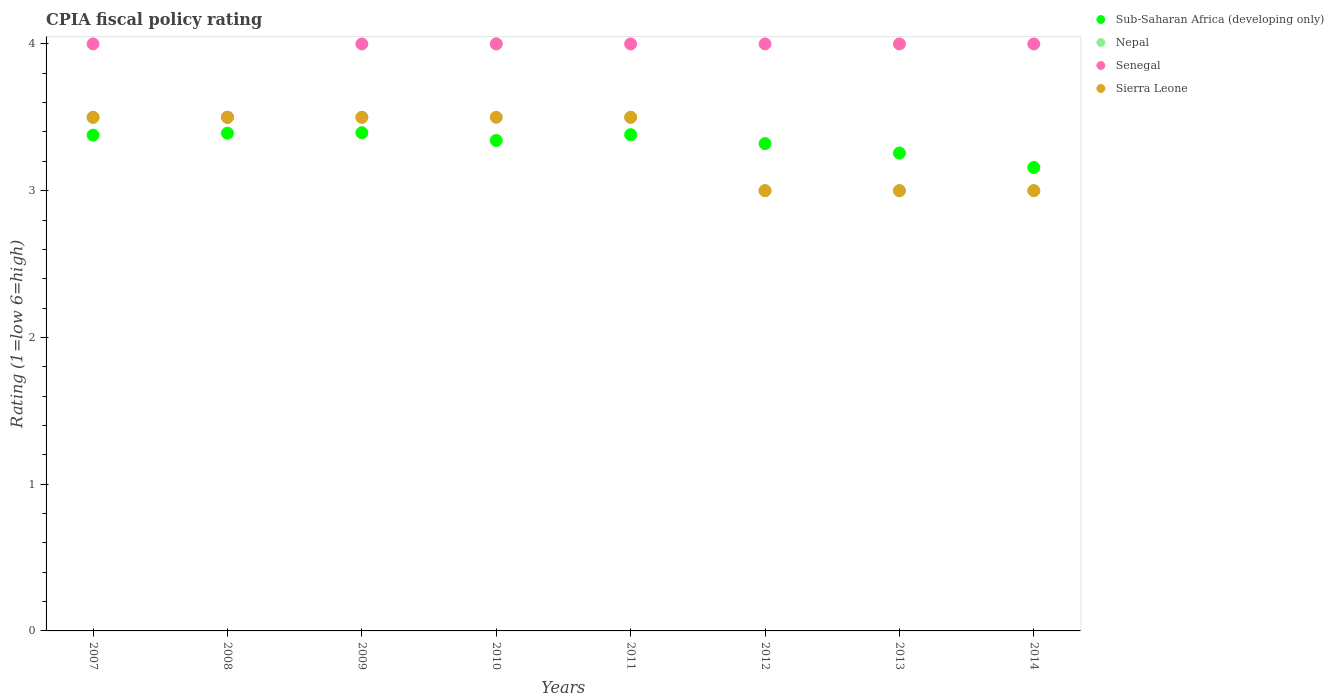Across all years, what is the maximum CPIA rating in Sub-Saharan Africa (developing only)?
Your answer should be very brief. 3.39. In which year was the CPIA rating in Nepal minimum?
Offer a terse response. 2012. What is the total CPIA rating in Sub-Saharan Africa (developing only) in the graph?
Provide a short and direct response. 26.62. What is the difference between the CPIA rating in Sub-Saharan Africa (developing only) in 2010 and that in 2012?
Provide a short and direct response. 0.02. What is the difference between the CPIA rating in Sierra Leone in 2011 and the CPIA rating in Sub-Saharan Africa (developing only) in 2014?
Your response must be concise. 0.34. What is the average CPIA rating in Sierra Leone per year?
Make the answer very short. 3.31. What is the ratio of the CPIA rating in Sub-Saharan Africa (developing only) in 2009 to that in 2014?
Offer a terse response. 1.07. Is the difference between the CPIA rating in Nepal in 2011 and 2013 greater than the difference between the CPIA rating in Sierra Leone in 2011 and 2013?
Your response must be concise. No. What is the difference between the highest and the second highest CPIA rating in Sub-Saharan Africa (developing only)?
Keep it short and to the point. 0. In how many years, is the CPIA rating in Sub-Saharan Africa (developing only) greater than the average CPIA rating in Sub-Saharan Africa (developing only) taken over all years?
Your response must be concise. 5. Is the sum of the CPIA rating in Nepal in 2009 and 2013 greater than the maximum CPIA rating in Senegal across all years?
Keep it short and to the point. Yes. Is the CPIA rating in Sub-Saharan Africa (developing only) strictly greater than the CPIA rating in Sierra Leone over the years?
Ensure brevity in your answer.  No. Is the CPIA rating in Sierra Leone strictly less than the CPIA rating in Senegal over the years?
Your answer should be very brief. No. How many legend labels are there?
Provide a succinct answer. 4. What is the title of the graph?
Provide a succinct answer. CPIA fiscal policy rating. Does "Monaco" appear as one of the legend labels in the graph?
Your response must be concise. No. What is the label or title of the X-axis?
Keep it short and to the point. Years. What is the label or title of the Y-axis?
Keep it short and to the point. Rating (1=low 6=high). What is the Rating (1=low 6=high) of Sub-Saharan Africa (developing only) in 2007?
Give a very brief answer. 3.38. What is the Rating (1=low 6=high) in Nepal in 2007?
Your response must be concise. 3.5. What is the Rating (1=low 6=high) of Senegal in 2007?
Give a very brief answer. 4. What is the Rating (1=low 6=high) of Sierra Leone in 2007?
Keep it short and to the point. 3.5. What is the Rating (1=low 6=high) in Sub-Saharan Africa (developing only) in 2008?
Offer a very short reply. 3.39. What is the Rating (1=low 6=high) of Nepal in 2008?
Ensure brevity in your answer.  3.5. What is the Rating (1=low 6=high) in Senegal in 2008?
Your answer should be very brief. 3.5. What is the Rating (1=low 6=high) of Sub-Saharan Africa (developing only) in 2009?
Your answer should be compact. 3.39. What is the Rating (1=low 6=high) in Nepal in 2009?
Ensure brevity in your answer.  3.5. What is the Rating (1=low 6=high) in Senegal in 2009?
Your answer should be compact. 4. What is the Rating (1=low 6=high) in Sub-Saharan Africa (developing only) in 2010?
Make the answer very short. 3.34. What is the Rating (1=low 6=high) of Nepal in 2010?
Offer a very short reply. 4. What is the Rating (1=low 6=high) in Sierra Leone in 2010?
Your response must be concise. 3.5. What is the Rating (1=low 6=high) in Sub-Saharan Africa (developing only) in 2011?
Your answer should be compact. 3.38. What is the Rating (1=low 6=high) of Senegal in 2011?
Your answer should be very brief. 4. What is the Rating (1=low 6=high) of Sub-Saharan Africa (developing only) in 2012?
Provide a succinct answer. 3.32. What is the Rating (1=low 6=high) in Sub-Saharan Africa (developing only) in 2013?
Your response must be concise. 3.26. What is the Rating (1=low 6=high) of Sub-Saharan Africa (developing only) in 2014?
Your response must be concise. 3.16. What is the Rating (1=low 6=high) in Nepal in 2014?
Give a very brief answer. 3. What is the Rating (1=low 6=high) in Senegal in 2014?
Your answer should be very brief. 4. What is the Rating (1=low 6=high) in Sierra Leone in 2014?
Your response must be concise. 3. Across all years, what is the maximum Rating (1=low 6=high) in Sub-Saharan Africa (developing only)?
Offer a very short reply. 3.39. Across all years, what is the maximum Rating (1=low 6=high) in Sierra Leone?
Offer a very short reply. 3.5. Across all years, what is the minimum Rating (1=low 6=high) in Sub-Saharan Africa (developing only)?
Your response must be concise. 3.16. Across all years, what is the minimum Rating (1=low 6=high) of Senegal?
Your answer should be compact. 3.5. What is the total Rating (1=low 6=high) of Sub-Saharan Africa (developing only) in the graph?
Offer a very short reply. 26.62. What is the total Rating (1=low 6=high) of Senegal in the graph?
Your answer should be very brief. 31.5. What is the total Rating (1=low 6=high) in Sierra Leone in the graph?
Give a very brief answer. 26.5. What is the difference between the Rating (1=low 6=high) in Sub-Saharan Africa (developing only) in 2007 and that in 2008?
Offer a terse response. -0.01. What is the difference between the Rating (1=low 6=high) in Senegal in 2007 and that in 2008?
Your answer should be very brief. 0.5. What is the difference between the Rating (1=low 6=high) in Sub-Saharan Africa (developing only) in 2007 and that in 2009?
Give a very brief answer. -0.02. What is the difference between the Rating (1=low 6=high) of Senegal in 2007 and that in 2009?
Ensure brevity in your answer.  0. What is the difference between the Rating (1=low 6=high) in Sub-Saharan Africa (developing only) in 2007 and that in 2010?
Provide a short and direct response. 0.04. What is the difference between the Rating (1=low 6=high) in Sierra Leone in 2007 and that in 2010?
Provide a short and direct response. 0. What is the difference between the Rating (1=low 6=high) of Sub-Saharan Africa (developing only) in 2007 and that in 2011?
Give a very brief answer. -0. What is the difference between the Rating (1=low 6=high) in Nepal in 2007 and that in 2011?
Your response must be concise. 0. What is the difference between the Rating (1=low 6=high) in Senegal in 2007 and that in 2011?
Your answer should be compact. 0. What is the difference between the Rating (1=low 6=high) of Sierra Leone in 2007 and that in 2011?
Make the answer very short. 0. What is the difference between the Rating (1=low 6=high) in Sub-Saharan Africa (developing only) in 2007 and that in 2012?
Offer a very short reply. 0.06. What is the difference between the Rating (1=low 6=high) of Nepal in 2007 and that in 2012?
Keep it short and to the point. 0.5. What is the difference between the Rating (1=low 6=high) of Senegal in 2007 and that in 2012?
Offer a terse response. 0. What is the difference between the Rating (1=low 6=high) of Sierra Leone in 2007 and that in 2012?
Give a very brief answer. 0.5. What is the difference between the Rating (1=low 6=high) in Sub-Saharan Africa (developing only) in 2007 and that in 2013?
Provide a succinct answer. 0.12. What is the difference between the Rating (1=low 6=high) in Nepal in 2007 and that in 2013?
Your answer should be very brief. 0.5. What is the difference between the Rating (1=low 6=high) of Senegal in 2007 and that in 2013?
Ensure brevity in your answer.  0. What is the difference between the Rating (1=low 6=high) of Sierra Leone in 2007 and that in 2013?
Offer a terse response. 0.5. What is the difference between the Rating (1=low 6=high) of Sub-Saharan Africa (developing only) in 2007 and that in 2014?
Give a very brief answer. 0.22. What is the difference between the Rating (1=low 6=high) of Nepal in 2007 and that in 2014?
Your response must be concise. 0.5. What is the difference between the Rating (1=low 6=high) of Sierra Leone in 2007 and that in 2014?
Provide a short and direct response. 0.5. What is the difference between the Rating (1=low 6=high) of Sub-Saharan Africa (developing only) in 2008 and that in 2009?
Provide a succinct answer. -0. What is the difference between the Rating (1=low 6=high) of Nepal in 2008 and that in 2009?
Your answer should be compact. 0. What is the difference between the Rating (1=low 6=high) of Senegal in 2008 and that in 2009?
Keep it short and to the point. -0.5. What is the difference between the Rating (1=low 6=high) in Sierra Leone in 2008 and that in 2009?
Your answer should be very brief. 0. What is the difference between the Rating (1=low 6=high) in Sub-Saharan Africa (developing only) in 2008 and that in 2010?
Your answer should be compact. 0.05. What is the difference between the Rating (1=low 6=high) in Sierra Leone in 2008 and that in 2010?
Offer a very short reply. 0. What is the difference between the Rating (1=low 6=high) of Sub-Saharan Africa (developing only) in 2008 and that in 2011?
Provide a succinct answer. 0.01. What is the difference between the Rating (1=low 6=high) of Senegal in 2008 and that in 2011?
Provide a succinct answer. -0.5. What is the difference between the Rating (1=low 6=high) of Sub-Saharan Africa (developing only) in 2008 and that in 2012?
Provide a succinct answer. 0.07. What is the difference between the Rating (1=low 6=high) of Nepal in 2008 and that in 2012?
Your answer should be compact. 0.5. What is the difference between the Rating (1=low 6=high) of Senegal in 2008 and that in 2012?
Offer a terse response. -0.5. What is the difference between the Rating (1=low 6=high) of Sierra Leone in 2008 and that in 2012?
Ensure brevity in your answer.  0.5. What is the difference between the Rating (1=low 6=high) in Sub-Saharan Africa (developing only) in 2008 and that in 2013?
Your answer should be very brief. 0.14. What is the difference between the Rating (1=low 6=high) in Sierra Leone in 2008 and that in 2013?
Your answer should be compact. 0.5. What is the difference between the Rating (1=low 6=high) of Sub-Saharan Africa (developing only) in 2008 and that in 2014?
Keep it short and to the point. 0.23. What is the difference between the Rating (1=low 6=high) of Nepal in 2008 and that in 2014?
Provide a short and direct response. 0.5. What is the difference between the Rating (1=low 6=high) in Senegal in 2008 and that in 2014?
Give a very brief answer. -0.5. What is the difference between the Rating (1=low 6=high) of Sub-Saharan Africa (developing only) in 2009 and that in 2010?
Offer a terse response. 0.05. What is the difference between the Rating (1=low 6=high) in Senegal in 2009 and that in 2010?
Make the answer very short. 0. What is the difference between the Rating (1=low 6=high) in Sub-Saharan Africa (developing only) in 2009 and that in 2011?
Provide a succinct answer. 0.01. What is the difference between the Rating (1=low 6=high) in Nepal in 2009 and that in 2011?
Keep it short and to the point. 0. What is the difference between the Rating (1=low 6=high) in Sub-Saharan Africa (developing only) in 2009 and that in 2012?
Your response must be concise. 0.07. What is the difference between the Rating (1=low 6=high) of Sierra Leone in 2009 and that in 2012?
Offer a terse response. 0.5. What is the difference between the Rating (1=low 6=high) of Sub-Saharan Africa (developing only) in 2009 and that in 2013?
Ensure brevity in your answer.  0.14. What is the difference between the Rating (1=low 6=high) of Sierra Leone in 2009 and that in 2013?
Offer a very short reply. 0.5. What is the difference between the Rating (1=low 6=high) in Sub-Saharan Africa (developing only) in 2009 and that in 2014?
Offer a terse response. 0.24. What is the difference between the Rating (1=low 6=high) in Nepal in 2009 and that in 2014?
Your answer should be very brief. 0.5. What is the difference between the Rating (1=low 6=high) of Senegal in 2009 and that in 2014?
Provide a short and direct response. 0. What is the difference between the Rating (1=low 6=high) of Sierra Leone in 2009 and that in 2014?
Make the answer very short. 0.5. What is the difference between the Rating (1=low 6=high) in Sub-Saharan Africa (developing only) in 2010 and that in 2011?
Your answer should be compact. -0.04. What is the difference between the Rating (1=low 6=high) of Nepal in 2010 and that in 2011?
Keep it short and to the point. 0.5. What is the difference between the Rating (1=low 6=high) of Senegal in 2010 and that in 2011?
Your answer should be very brief. 0. What is the difference between the Rating (1=low 6=high) in Sub-Saharan Africa (developing only) in 2010 and that in 2012?
Give a very brief answer. 0.02. What is the difference between the Rating (1=low 6=high) in Senegal in 2010 and that in 2012?
Offer a very short reply. 0. What is the difference between the Rating (1=low 6=high) of Sub-Saharan Africa (developing only) in 2010 and that in 2013?
Your answer should be very brief. 0.09. What is the difference between the Rating (1=low 6=high) of Nepal in 2010 and that in 2013?
Offer a very short reply. 1. What is the difference between the Rating (1=low 6=high) in Senegal in 2010 and that in 2013?
Ensure brevity in your answer.  0. What is the difference between the Rating (1=low 6=high) in Sierra Leone in 2010 and that in 2013?
Offer a very short reply. 0.5. What is the difference between the Rating (1=low 6=high) in Sub-Saharan Africa (developing only) in 2010 and that in 2014?
Your answer should be compact. 0.18. What is the difference between the Rating (1=low 6=high) in Senegal in 2010 and that in 2014?
Offer a terse response. 0. What is the difference between the Rating (1=low 6=high) of Sub-Saharan Africa (developing only) in 2011 and that in 2012?
Offer a very short reply. 0.06. What is the difference between the Rating (1=low 6=high) in Nepal in 2011 and that in 2012?
Provide a succinct answer. 0.5. What is the difference between the Rating (1=low 6=high) of Sierra Leone in 2011 and that in 2012?
Provide a short and direct response. 0.5. What is the difference between the Rating (1=low 6=high) in Sub-Saharan Africa (developing only) in 2011 and that in 2013?
Offer a terse response. 0.13. What is the difference between the Rating (1=low 6=high) in Nepal in 2011 and that in 2013?
Give a very brief answer. 0.5. What is the difference between the Rating (1=low 6=high) in Sub-Saharan Africa (developing only) in 2011 and that in 2014?
Provide a short and direct response. 0.22. What is the difference between the Rating (1=low 6=high) in Nepal in 2011 and that in 2014?
Offer a very short reply. 0.5. What is the difference between the Rating (1=low 6=high) in Sub-Saharan Africa (developing only) in 2012 and that in 2013?
Offer a very short reply. 0.06. What is the difference between the Rating (1=low 6=high) in Nepal in 2012 and that in 2013?
Offer a terse response. 0. What is the difference between the Rating (1=low 6=high) of Sub-Saharan Africa (developing only) in 2012 and that in 2014?
Keep it short and to the point. 0.16. What is the difference between the Rating (1=low 6=high) of Nepal in 2012 and that in 2014?
Provide a short and direct response. 0. What is the difference between the Rating (1=low 6=high) of Sub-Saharan Africa (developing only) in 2013 and that in 2014?
Your answer should be compact. 0.1. What is the difference between the Rating (1=low 6=high) of Nepal in 2013 and that in 2014?
Give a very brief answer. 0. What is the difference between the Rating (1=low 6=high) of Sub-Saharan Africa (developing only) in 2007 and the Rating (1=low 6=high) of Nepal in 2008?
Offer a very short reply. -0.12. What is the difference between the Rating (1=low 6=high) in Sub-Saharan Africa (developing only) in 2007 and the Rating (1=low 6=high) in Senegal in 2008?
Provide a short and direct response. -0.12. What is the difference between the Rating (1=low 6=high) in Sub-Saharan Africa (developing only) in 2007 and the Rating (1=low 6=high) in Sierra Leone in 2008?
Keep it short and to the point. -0.12. What is the difference between the Rating (1=low 6=high) in Sub-Saharan Africa (developing only) in 2007 and the Rating (1=low 6=high) in Nepal in 2009?
Ensure brevity in your answer.  -0.12. What is the difference between the Rating (1=low 6=high) in Sub-Saharan Africa (developing only) in 2007 and the Rating (1=low 6=high) in Senegal in 2009?
Offer a very short reply. -0.62. What is the difference between the Rating (1=low 6=high) of Sub-Saharan Africa (developing only) in 2007 and the Rating (1=low 6=high) of Sierra Leone in 2009?
Make the answer very short. -0.12. What is the difference between the Rating (1=low 6=high) in Sub-Saharan Africa (developing only) in 2007 and the Rating (1=low 6=high) in Nepal in 2010?
Offer a terse response. -0.62. What is the difference between the Rating (1=low 6=high) of Sub-Saharan Africa (developing only) in 2007 and the Rating (1=low 6=high) of Senegal in 2010?
Your answer should be very brief. -0.62. What is the difference between the Rating (1=low 6=high) of Sub-Saharan Africa (developing only) in 2007 and the Rating (1=low 6=high) of Sierra Leone in 2010?
Offer a very short reply. -0.12. What is the difference between the Rating (1=low 6=high) of Senegal in 2007 and the Rating (1=low 6=high) of Sierra Leone in 2010?
Offer a very short reply. 0.5. What is the difference between the Rating (1=low 6=high) of Sub-Saharan Africa (developing only) in 2007 and the Rating (1=low 6=high) of Nepal in 2011?
Ensure brevity in your answer.  -0.12. What is the difference between the Rating (1=low 6=high) of Sub-Saharan Africa (developing only) in 2007 and the Rating (1=low 6=high) of Senegal in 2011?
Offer a terse response. -0.62. What is the difference between the Rating (1=low 6=high) of Sub-Saharan Africa (developing only) in 2007 and the Rating (1=low 6=high) of Sierra Leone in 2011?
Give a very brief answer. -0.12. What is the difference between the Rating (1=low 6=high) in Nepal in 2007 and the Rating (1=low 6=high) in Sierra Leone in 2011?
Your response must be concise. 0. What is the difference between the Rating (1=low 6=high) of Sub-Saharan Africa (developing only) in 2007 and the Rating (1=low 6=high) of Nepal in 2012?
Make the answer very short. 0.38. What is the difference between the Rating (1=low 6=high) in Sub-Saharan Africa (developing only) in 2007 and the Rating (1=low 6=high) in Senegal in 2012?
Provide a succinct answer. -0.62. What is the difference between the Rating (1=low 6=high) in Sub-Saharan Africa (developing only) in 2007 and the Rating (1=low 6=high) in Sierra Leone in 2012?
Offer a terse response. 0.38. What is the difference between the Rating (1=low 6=high) of Nepal in 2007 and the Rating (1=low 6=high) of Sierra Leone in 2012?
Your response must be concise. 0.5. What is the difference between the Rating (1=low 6=high) of Senegal in 2007 and the Rating (1=low 6=high) of Sierra Leone in 2012?
Ensure brevity in your answer.  1. What is the difference between the Rating (1=low 6=high) of Sub-Saharan Africa (developing only) in 2007 and the Rating (1=low 6=high) of Nepal in 2013?
Ensure brevity in your answer.  0.38. What is the difference between the Rating (1=low 6=high) of Sub-Saharan Africa (developing only) in 2007 and the Rating (1=low 6=high) of Senegal in 2013?
Keep it short and to the point. -0.62. What is the difference between the Rating (1=low 6=high) in Sub-Saharan Africa (developing only) in 2007 and the Rating (1=low 6=high) in Sierra Leone in 2013?
Make the answer very short. 0.38. What is the difference between the Rating (1=low 6=high) of Nepal in 2007 and the Rating (1=low 6=high) of Senegal in 2013?
Keep it short and to the point. -0.5. What is the difference between the Rating (1=low 6=high) in Nepal in 2007 and the Rating (1=low 6=high) in Sierra Leone in 2013?
Provide a short and direct response. 0.5. What is the difference between the Rating (1=low 6=high) in Sub-Saharan Africa (developing only) in 2007 and the Rating (1=low 6=high) in Nepal in 2014?
Provide a short and direct response. 0.38. What is the difference between the Rating (1=low 6=high) in Sub-Saharan Africa (developing only) in 2007 and the Rating (1=low 6=high) in Senegal in 2014?
Offer a very short reply. -0.62. What is the difference between the Rating (1=low 6=high) of Sub-Saharan Africa (developing only) in 2007 and the Rating (1=low 6=high) of Sierra Leone in 2014?
Give a very brief answer. 0.38. What is the difference between the Rating (1=low 6=high) in Nepal in 2007 and the Rating (1=low 6=high) in Senegal in 2014?
Provide a succinct answer. -0.5. What is the difference between the Rating (1=low 6=high) in Senegal in 2007 and the Rating (1=low 6=high) in Sierra Leone in 2014?
Give a very brief answer. 1. What is the difference between the Rating (1=low 6=high) in Sub-Saharan Africa (developing only) in 2008 and the Rating (1=low 6=high) in Nepal in 2009?
Make the answer very short. -0.11. What is the difference between the Rating (1=low 6=high) in Sub-Saharan Africa (developing only) in 2008 and the Rating (1=low 6=high) in Senegal in 2009?
Provide a succinct answer. -0.61. What is the difference between the Rating (1=low 6=high) in Sub-Saharan Africa (developing only) in 2008 and the Rating (1=low 6=high) in Sierra Leone in 2009?
Your response must be concise. -0.11. What is the difference between the Rating (1=low 6=high) in Nepal in 2008 and the Rating (1=low 6=high) in Senegal in 2009?
Your response must be concise. -0.5. What is the difference between the Rating (1=low 6=high) of Nepal in 2008 and the Rating (1=low 6=high) of Sierra Leone in 2009?
Offer a very short reply. 0. What is the difference between the Rating (1=low 6=high) of Senegal in 2008 and the Rating (1=low 6=high) of Sierra Leone in 2009?
Make the answer very short. 0. What is the difference between the Rating (1=low 6=high) in Sub-Saharan Africa (developing only) in 2008 and the Rating (1=low 6=high) in Nepal in 2010?
Ensure brevity in your answer.  -0.61. What is the difference between the Rating (1=low 6=high) in Sub-Saharan Africa (developing only) in 2008 and the Rating (1=low 6=high) in Senegal in 2010?
Provide a short and direct response. -0.61. What is the difference between the Rating (1=low 6=high) of Sub-Saharan Africa (developing only) in 2008 and the Rating (1=low 6=high) of Sierra Leone in 2010?
Your response must be concise. -0.11. What is the difference between the Rating (1=low 6=high) in Nepal in 2008 and the Rating (1=low 6=high) in Senegal in 2010?
Provide a short and direct response. -0.5. What is the difference between the Rating (1=low 6=high) of Nepal in 2008 and the Rating (1=low 6=high) of Sierra Leone in 2010?
Make the answer very short. 0. What is the difference between the Rating (1=low 6=high) of Senegal in 2008 and the Rating (1=low 6=high) of Sierra Leone in 2010?
Make the answer very short. 0. What is the difference between the Rating (1=low 6=high) of Sub-Saharan Africa (developing only) in 2008 and the Rating (1=low 6=high) of Nepal in 2011?
Ensure brevity in your answer.  -0.11. What is the difference between the Rating (1=low 6=high) in Sub-Saharan Africa (developing only) in 2008 and the Rating (1=low 6=high) in Senegal in 2011?
Your response must be concise. -0.61. What is the difference between the Rating (1=low 6=high) in Sub-Saharan Africa (developing only) in 2008 and the Rating (1=low 6=high) in Sierra Leone in 2011?
Your response must be concise. -0.11. What is the difference between the Rating (1=low 6=high) in Nepal in 2008 and the Rating (1=low 6=high) in Senegal in 2011?
Your response must be concise. -0.5. What is the difference between the Rating (1=low 6=high) of Nepal in 2008 and the Rating (1=low 6=high) of Sierra Leone in 2011?
Provide a short and direct response. 0. What is the difference between the Rating (1=low 6=high) in Senegal in 2008 and the Rating (1=low 6=high) in Sierra Leone in 2011?
Offer a very short reply. 0. What is the difference between the Rating (1=low 6=high) of Sub-Saharan Africa (developing only) in 2008 and the Rating (1=low 6=high) of Nepal in 2012?
Ensure brevity in your answer.  0.39. What is the difference between the Rating (1=low 6=high) in Sub-Saharan Africa (developing only) in 2008 and the Rating (1=low 6=high) in Senegal in 2012?
Give a very brief answer. -0.61. What is the difference between the Rating (1=low 6=high) in Sub-Saharan Africa (developing only) in 2008 and the Rating (1=low 6=high) in Sierra Leone in 2012?
Give a very brief answer. 0.39. What is the difference between the Rating (1=low 6=high) of Nepal in 2008 and the Rating (1=low 6=high) of Sierra Leone in 2012?
Keep it short and to the point. 0.5. What is the difference between the Rating (1=low 6=high) of Sub-Saharan Africa (developing only) in 2008 and the Rating (1=low 6=high) of Nepal in 2013?
Provide a succinct answer. 0.39. What is the difference between the Rating (1=low 6=high) in Sub-Saharan Africa (developing only) in 2008 and the Rating (1=low 6=high) in Senegal in 2013?
Your answer should be compact. -0.61. What is the difference between the Rating (1=low 6=high) of Sub-Saharan Africa (developing only) in 2008 and the Rating (1=low 6=high) of Sierra Leone in 2013?
Offer a very short reply. 0.39. What is the difference between the Rating (1=low 6=high) in Nepal in 2008 and the Rating (1=low 6=high) in Senegal in 2013?
Provide a succinct answer. -0.5. What is the difference between the Rating (1=low 6=high) in Sub-Saharan Africa (developing only) in 2008 and the Rating (1=low 6=high) in Nepal in 2014?
Provide a short and direct response. 0.39. What is the difference between the Rating (1=low 6=high) of Sub-Saharan Africa (developing only) in 2008 and the Rating (1=low 6=high) of Senegal in 2014?
Your answer should be compact. -0.61. What is the difference between the Rating (1=low 6=high) in Sub-Saharan Africa (developing only) in 2008 and the Rating (1=low 6=high) in Sierra Leone in 2014?
Provide a succinct answer. 0.39. What is the difference between the Rating (1=low 6=high) of Nepal in 2008 and the Rating (1=low 6=high) of Sierra Leone in 2014?
Your response must be concise. 0.5. What is the difference between the Rating (1=low 6=high) in Senegal in 2008 and the Rating (1=low 6=high) in Sierra Leone in 2014?
Keep it short and to the point. 0.5. What is the difference between the Rating (1=low 6=high) of Sub-Saharan Africa (developing only) in 2009 and the Rating (1=low 6=high) of Nepal in 2010?
Make the answer very short. -0.61. What is the difference between the Rating (1=low 6=high) of Sub-Saharan Africa (developing only) in 2009 and the Rating (1=low 6=high) of Senegal in 2010?
Your answer should be compact. -0.61. What is the difference between the Rating (1=low 6=high) in Sub-Saharan Africa (developing only) in 2009 and the Rating (1=low 6=high) in Sierra Leone in 2010?
Keep it short and to the point. -0.11. What is the difference between the Rating (1=low 6=high) in Nepal in 2009 and the Rating (1=low 6=high) in Senegal in 2010?
Keep it short and to the point. -0.5. What is the difference between the Rating (1=low 6=high) in Nepal in 2009 and the Rating (1=low 6=high) in Sierra Leone in 2010?
Make the answer very short. 0. What is the difference between the Rating (1=low 6=high) in Sub-Saharan Africa (developing only) in 2009 and the Rating (1=low 6=high) in Nepal in 2011?
Offer a terse response. -0.11. What is the difference between the Rating (1=low 6=high) in Sub-Saharan Africa (developing only) in 2009 and the Rating (1=low 6=high) in Senegal in 2011?
Provide a short and direct response. -0.61. What is the difference between the Rating (1=low 6=high) in Sub-Saharan Africa (developing only) in 2009 and the Rating (1=low 6=high) in Sierra Leone in 2011?
Provide a succinct answer. -0.11. What is the difference between the Rating (1=low 6=high) in Senegal in 2009 and the Rating (1=low 6=high) in Sierra Leone in 2011?
Provide a short and direct response. 0.5. What is the difference between the Rating (1=low 6=high) in Sub-Saharan Africa (developing only) in 2009 and the Rating (1=low 6=high) in Nepal in 2012?
Make the answer very short. 0.39. What is the difference between the Rating (1=low 6=high) in Sub-Saharan Africa (developing only) in 2009 and the Rating (1=low 6=high) in Senegal in 2012?
Ensure brevity in your answer.  -0.61. What is the difference between the Rating (1=low 6=high) of Sub-Saharan Africa (developing only) in 2009 and the Rating (1=low 6=high) of Sierra Leone in 2012?
Make the answer very short. 0.39. What is the difference between the Rating (1=low 6=high) in Nepal in 2009 and the Rating (1=low 6=high) in Senegal in 2012?
Provide a short and direct response. -0.5. What is the difference between the Rating (1=low 6=high) of Nepal in 2009 and the Rating (1=low 6=high) of Sierra Leone in 2012?
Your answer should be very brief. 0.5. What is the difference between the Rating (1=low 6=high) in Sub-Saharan Africa (developing only) in 2009 and the Rating (1=low 6=high) in Nepal in 2013?
Ensure brevity in your answer.  0.39. What is the difference between the Rating (1=low 6=high) of Sub-Saharan Africa (developing only) in 2009 and the Rating (1=low 6=high) of Senegal in 2013?
Offer a terse response. -0.61. What is the difference between the Rating (1=low 6=high) in Sub-Saharan Africa (developing only) in 2009 and the Rating (1=low 6=high) in Sierra Leone in 2013?
Provide a succinct answer. 0.39. What is the difference between the Rating (1=low 6=high) of Nepal in 2009 and the Rating (1=low 6=high) of Sierra Leone in 2013?
Ensure brevity in your answer.  0.5. What is the difference between the Rating (1=low 6=high) in Sub-Saharan Africa (developing only) in 2009 and the Rating (1=low 6=high) in Nepal in 2014?
Your answer should be very brief. 0.39. What is the difference between the Rating (1=low 6=high) of Sub-Saharan Africa (developing only) in 2009 and the Rating (1=low 6=high) of Senegal in 2014?
Offer a very short reply. -0.61. What is the difference between the Rating (1=low 6=high) of Sub-Saharan Africa (developing only) in 2009 and the Rating (1=low 6=high) of Sierra Leone in 2014?
Your response must be concise. 0.39. What is the difference between the Rating (1=low 6=high) in Nepal in 2009 and the Rating (1=low 6=high) in Senegal in 2014?
Offer a terse response. -0.5. What is the difference between the Rating (1=low 6=high) of Nepal in 2009 and the Rating (1=low 6=high) of Sierra Leone in 2014?
Ensure brevity in your answer.  0.5. What is the difference between the Rating (1=low 6=high) in Senegal in 2009 and the Rating (1=low 6=high) in Sierra Leone in 2014?
Make the answer very short. 1. What is the difference between the Rating (1=low 6=high) of Sub-Saharan Africa (developing only) in 2010 and the Rating (1=low 6=high) of Nepal in 2011?
Your answer should be very brief. -0.16. What is the difference between the Rating (1=low 6=high) of Sub-Saharan Africa (developing only) in 2010 and the Rating (1=low 6=high) of Senegal in 2011?
Provide a short and direct response. -0.66. What is the difference between the Rating (1=low 6=high) in Sub-Saharan Africa (developing only) in 2010 and the Rating (1=low 6=high) in Sierra Leone in 2011?
Ensure brevity in your answer.  -0.16. What is the difference between the Rating (1=low 6=high) in Sub-Saharan Africa (developing only) in 2010 and the Rating (1=low 6=high) in Nepal in 2012?
Offer a terse response. 0.34. What is the difference between the Rating (1=low 6=high) of Sub-Saharan Africa (developing only) in 2010 and the Rating (1=low 6=high) of Senegal in 2012?
Offer a terse response. -0.66. What is the difference between the Rating (1=low 6=high) of Sub-Saharan Africa (developing only) in 2010 and the Rating (1=low 6=high) of Sierra Leone in 2012?
Provide a succinct answer. 0.34. What is the difference between the Rating (1=low 6=high) in Nepal in 2010 and the Rating (1=low 6=high) in Sierra Leone in 2012?
Ensure brevity in your answer.  1. What is the difference between the Rating (1=low 6=high) in Sub-Saharan Africa (developing only) in 2010 and the Rating (1=low 6=high) in Nepal in 2013?
Keep it short and to the point. 0.34. What is the difference between the Rating (1=low 6=high) in Sub-Saharan Africa (developing only) in 2010 and the Rating (1=low 6=high) in Senegal in 2013?
Ensure brevity in your answer.  -0.66. What is the difference between the Rating (1=low 6=high) in Sub-Saharan Africa (developing only) in 2010 and the Rating (1=low 6=high) in Sierra Leone in 2013?
Offer a terse response. 0.34. What is the difference between the Rating (1=low 6=high) in Nepal in 2010 and the Rating (1=low 6=high) in Senegal in 2013?
Your response must be concise. 0. What is the difference between the Rating (1=low 6=high) of Sub-Saharan Africa (developing only) in 2010 and the Rating (1=low 6=high) of Nepal in 2014?
Ensure brevity in your answer.  0.34. What is the difference between the Rating (1=low 6=high) of Sub-Saharan Africa (developing only) in 2010 and the Rating (1=low 6=high) of Senegal in 2014?
Offer a terse response. -0.66. What is the difference between the Rating (1=low 6=high) in Sub-Saharan Africa (developing only) in 2010 and the Rating (1=low 6=high) in Sierra Leone in 2014?
Make the answer very short. 0.34. What is the difference between the Rating (1=low 6=high) of Nepal in 2010 and the Rating (1=low 6=high) of Sierra Leone in 2014?
Give a very brief answer. 1. What is the difference between the Rating (1=low 6=high) of Sub-Saharan Africa (developing only) in 2011 and the Rating (1=low 6=high) of Nepal in 2012?
Offer a very short reply. 0.38. What is the difference between the Rating (1=low 6=high) in Sub-Saharan Africa (developing only) in 2011 and the Rating (1=low 6=high) in Senegal in 2012?
Your answer should be compact. -0.62. What is the difference between the Rating (1=low 6=high) of Sub-Saharan Africa (developing only) in 2011 and the Rating (1=low 6=high) of Sierra Leone in 2012?
Keep it short and to the point. 0.38. What is the difference between the Rating (1=low 6=high) of Nepal in 2011 and the Rating (1=low 6=high) of Senegal in 2012?
Offer a terse response. -0.5. What is the difference between the Rating (1=low 6=high) of Nepal in 2011 and the Rating (1=low 6=high) of Sierra Leone in 2012?
Give a very brief answer. 0.5. What is the difference between the Rating (1=low 6=high) of Senegal in 2011 and the Rating (1=low 6=high) of Sierra Leone in 2012?
Your answer should be compact. 1. What is the difference between the Rating (1=low 6=high) in Sub-Saharan Africa (developing only) in 2011 and the Rating (1=low 6=high) in Nepal in 2013?
Your answer should be compact. 0.38. What is the difference between the Rating (1=low 6=high) of Sub-Saharan Africa (developing only) in 2011 and the Rating (1=low 6=high) of Senegal in 2013?
Your answer should be compact. -0.62. What is the difference between the Rating (1=low 6=high) of Sub-Saharan Africa (developing only) in 2011 and the Rating (1=low 6=high) of Sierra Leone in 2013?
Your answer should be very brief. 0.38. What is the difference between the Rating (1=low 6=high) of Sub-Saharan Africa (developing only) in 2011 and the Rating (1=low 6=high) of Nepal in 2014?
Your response must be concise. 0.38. What is the difference between the Rating (1=low 6=high) in Sub-Saharan Africa (developing only) in 2011 and the Rating (1=low 6=high) in Senegal in 2014?
Make the answer very short. -0.62. What is the difference between the Rating (1=low 6=high) of Sub-Saharan Africa (developing only) in 2011 and the Rating (1=low 6=high) of Sierra Leone in 2014?
Offer a terse response. 0.38. What is the difference between the Rating (1=low 6=high) of Nepal in 2011 and the Rating (1=low 6=high) of Senegal in 2014?
Provide a succinct answer. -0.5. What is the difference between the Rating (1=low 6=high) of Sub-Saharan Africa (developing only) in 2012 and the Rating (1=low 6=high) of Nepal in 2013?
Your response must be concise. 0.32. What is the difference between the Rating (1=low 6=high) of Sub-Saharan Africa (developing only) in 2012 and the Rating (1=low 6=high) of Senegal in 2013?
Keep it short and to the point. -0.68. What is the difference between the Rating (1=low 6=high) in Sub-Saharan Africa (developing only) in 2012 and the Rating (1=low 6=high) in Sierra Leone in 2013?
Your answer should be compact. 0.32. What is the difference between the Rating (1=low 6=high) of Nepal in 2012 and the Rating (1=low 6=high) of Sierra Leone in 2013?
Your response must be concise. 0. What is the difference between the Rating (1=low 6=high) in Sub-Saharan Africa (developing only) in 2012 and the Rating (1=low 6=high) in Nepal in 2014?
Provide a succinct answer. 0.32. What is the difference between the Rating (1=low 6=high) in Sub-Saharan Africa (developing only) in 2012 and the Rating (1=low 6=high) in Senegal in 2014?
Keep it short and to the point. -0.68. What is the difference between the Rating (1=low 6=high) in Sub-Saharan Africa (developing only) in 2012 and the Rating (1=low 6=high) in Sierra Leone in 2014?
Keep it short and to the point. 0.32. What is the difference between the Rating (1=low 6=high) in Nepal in 2012 and the Rating (1=low 6=high) in Senegal in 2014?
Your response must be concise. -1. What is the difference between the Rating (1=low 6=high) of Sub-Saharan Africa (developing only) in 2013 and the Rating (1=low 6=high) of Nepal in 2014?
Your response must be concise. 0.26. What is the difference between the Rating (1=low 6=high) of Sub-Saharan Africa (developing only) in 2013 and the Rating (1=low 6=high) of Senegal in 2014?
Provide a short and direct response. -0.74. What is the difference between the Rating (1=low 6=high) in Sub-Saharan Africa (developing only) in 2013 and the Rating (1=low 6=high) in Sierra Leone in 2014?
Make the answer very short. 0.26. What is the difference between the Rating (1=low 6=high) in Nepal in 2013 and the Rating (1=low 6=high) in Senegal in 2014?
Provide a succinct answer. -1. What is the difference between the Rating (1=low 6=high) in Nepal in 2013 and the Rating (1=low 6=high) in Sierra Leone in 2014?
Offer a terse response. 0. What is the difference between the Rating (1=low 6=high) in Senegal in 2013 and the Rating (1=low 6=high) in Sierra Leone in 2014?
Your answer should be compact. 1. What is the average Rating (1=low 6=high) of Sub-Saharan Africa (developing only) per year?
Give a very brief answer. 3.33. What is the average Rating (1=low 6=high) of Nepal per year?
Your response must be concise. 3.38. What is the average Rating (1=low 6=high) in Senegal per year?
Keep it short and to the point. 3.94. What is the average Rating (1=low 6=high) in Sierra Leone per year?
Keep it short and to the point. 3.31. In the year 2007, what is the difference between the Rating (1=low 6=high) in Sub-Saharan Africa (developing only) and Rating (1=low 6=high) in Nepal?
Your response must be concise. -0.12. In the year 2007, what is the difference between the Rating (1=low 6=high) in Sub-Saharan Africa (developing only) and Rating (1=low 6=high) in Senegal?
Provide a short and direct response. -0.62. In the year 2007, what is the difference between the Rating (1=low 6=high) in Sub-Saharan Africa (developing only) and Rating (1=low 6=high) in Sierra Leone?
Your response must be concise. -0.12. In the year 2008, what is the difference between the Rating (1=low 6=high) in Sub-Saharan Africa (developing only) and Rating (1=low 6=high) in Nepal?
Keep it short and to the point. -0.11. In the year 2008, what is the difference between the Rating (1=low 6=high) in Sub-Saharan Africa (developing only) and Rating (1=low 6=high) in Senegal?
Offer a terse response. -0.11. In the year 2008, what is the difference between the Rating (1=low 6=high) in Sub-Saharan Africa (developing only) and Rating (1=low 6=high) in Sierra Leone?
Offer a terse response. -0.11. In the year 2008, what is the difference between the Rating (1=low 6=high) in Nepal and Rating (1=low 6=high) in Senegal?
Offer a terse response. 0. In the year 2009, what is the difference between the Rating (1=low 6=high) of Sub-Saharan Africa (developing only) and Rating (1=low 6=high) of Nepal?
Make the answer very short. -0.11. In the year 2009, what is the difference between the Rating (1=low 6=high) of Sub-Saharan Africa (developing only) and Rating (1=low 6=high) of Senegal?
Ensure brevity in your answer.  -0.61. In the year 2009, what is the difference between the Rating (1=low 6=high) in Sub-Saharan Africa (developing only) and Rating (1=low 6=high) in Sierra Leone?
Your answer should be very brief. -0.11. In the year 2009, what is the difference between the Rating (1=low 6=high) of Nepal and Rating (1=low 6=high) of Senegal?
Offer a very short reply. -0.5. In the year 2009, what is the difference between the Rating (1=low 6=high) in Senegal and Rating (1=low 6=high) in Sierra Leone?
Provide a short and direct response. 0.5. In the year 2010, what is the difference between the Rating (1=low 6=high) in Sub-Saharan Africa (developing only) and Rating (1=low 6=high) in Nepal?
Your answer should be compact. -0.66. In the year 2010, what is the difference between the Rating (1=low 6=high) of Sub-Saharan Africa (developing only) and Rating (1=low 6=high) of Senegal?
Your answer should be very brief. -0.66. In the year 2010, what is the difference between the Rating (1=low 6=high) of Sub-Saharan Africa (developing only) and Rating (1=low 6=high) of Sierra Leone?
Give a very brief answer. -0.16. In the year 2010, what is the difference between the Rating (1=low 6=high) in Nepal and Rating (1=low 6=high) in Sierra Leone?
Offer a very short reply. 0.5. In the year 2010, what is the difference between the Rating (1=low 6=high) in Senegal and Rating (1=low 6=high) in Sierra Leone?
Your answer should be compact. 0.5. In the year 2011, what is the difference between the Rating (1=low 6=high) of Sub-Saharan Africa (developing only) and Rating (1=low 6=high) of Nepal?
Offer a terse response. -0.12. In the year 2011, what is the difference between the Rating (1=low 6=high) in Sub-Saharan Africa (developing only) and Rating (1=low 6=high) in Senegal?
Keep it short and to the point. -0.62. In the year 2011, what is the difference between the Rating (1=low 6=high) in Sub-Saharan Africa (developing only) and Rating (1=low 6=high) in Sierra Leone?
Give a very brief answer. -0.12. In the year 2011, what is the difference between the Rating (1=low 6=high) in Nepal and Rating (1=low 6=high) in Senegal?
Your answer should be very brief. -0.5. In the year 2011, what is the difference between the Rating (1=low 6=high) of Nepal and Rating (1=low 6=high) of Sierra Leone?
Offer a very short reply. 0. In the year 2012, what is the difference between the Rating (1=low 6=high) in Sub-Saharan Africa (developing only) and Rating (1=low 6=high) in Nepal?
Your answer should be very brief. 0.32. In the year 2012, what is the difference between the Rating (1=low 6=high) in Sub-Saharan Africa (developing only) and Rating (1=low 6=high) in Senegal?
Make the answer very short. -0.68. In the year 2012, what is the difference between the Rating (1=low 6=high) in Sub-Saharan Africa (developing only) and Rating (1=low 6=high) in Sierra Leone?
Make the answer very short. 0.32. In the year 2012, what is the difference between the Rating (1=low 6=high) in Nepal and Rating (1=low 6=high) in Sierra Leone?
Give a very brief answer. 0. In the year 2013, what is the difference between the Rating (1=low 6=high) of Sub-Saharan Africa (developing only) and Rating (1=low 6=high) of Nepal?
Your response must be concise. 0.26. In the year 2013, what is the difference between the Rating (1=low 6=high) in Sub-Saharan Africa (developing only) and Rating (1=low 6=high) in Senegal?
Provide a succinct answer. -0.74. In the year 2013, what is the difference between the Rating (1=low 6=high) of Sub-Saharan Africa (developing only) and Rating (1=low 6=high) of Sierra Leone?
Provide a succinct answer. 0.26. In the year 2013, what is the difference between the Rating (1=low 6=high) in Nepal and Rating (1=low 6=high) in Sierra Leone?
Provide a succinct answer. 0. In the year 2014, what is the difference between the Rating (1=low 6=high) in Sub-Saharan Africa (developing only) and Rating (1=low 6=high) in Nepal?
Offer a very short reply. 0.16. In the year 2014, what is the difference between the Rating (1=low 6=high) in Sub-Saharan Africa (developing only) and Rating (1=low 6=high) in Senegal?
Provide a succinct answer. -0.84. In the year 2014, what is the difference between the Rating (1=low 6=high) of Sub-Saharan Africa (developing only) and Rating (1=low 6=high) of Sierra Leone?
Make the answer very short. 0.16. In the year 2014, what is the difference between the Rating (1=low 6=high) of Nepal and Rating (1=low 6=high) of Sierra Leone?
Provide a short and direct response. 0. What is the ratio of the Rating (1=low 6=high) of Sub-Saharan Africa (developing only) in 2007 to that in 2008?
Keep it short and to the point. 1. What is the ratio of the Rating (1=low 6=high) of Nepal in 2007 to that in 2008?
Your answer should be very brief. 1. What is the ratio of the Rating (1=low 6=high) of Senegal in 2007 to that in 2008?
Give a very brief answer. 1.14. What is the ratio of the Rating (1=low 6=high) in Sierra Leone in 2007 to that in 2008?
Make the answer very short. 1. What is the ratio of the Rating (1=low 6=high) of Nepal in 2007 to that in 2009?
Ensure brevity in your answer.  1. What is the ratio of the Rating (1=low 6=high) of Sub-Saharan Africa (developing only) in 2007 to that in 2010?
Give a very brief answer. 1.01. What is the ratio of the Rating (1=low 6=high) of Nepal in 2007 to that in 2010?
Provide a succinct answer. 0.88. What is the ratio of the Rating (1=low 6=high) of Sierra Leone in 2007 to that in 2010?
Offer a very short reply. 1. What is the ratio of the Rating (1=low 6=high) of Sub-Saharan Africa (developing only) in 2007 to that in 2012?
Make the answer very short. 1.02. What is the ratio of the Rating (1=low 6=high) in Senegal in 2007 to that in 2012?
Provide a succinct answer. 1. What is the ratio of the Rating (1=low 6=high) in Sub-Saharan Africa (developing only) in 2007 to that in 2013?
Your answer should be very brief. 1.04. What is the ratio of the Rating (1=low 6=high) in Sierra Leone in 2007 to that in 2013?
Your answer should be compact. 1.17. What is the ratio of the Rating (1=low 6=high) of Sub-Saharan Africa (developing only) in 2007 to that in 2014?
Your answer should be very brief. 1.07. What is the ratio of the Rating (1=low 6=high) in Sierra Leone in 2008 to that in 2009?
Keep it short and to the point. 1. What is the ratio of the Rating (1=low 6=high) in Sub-Saharan Africa (developing only) in 2008 to that in 2010?
Your answer should be compact. 1.01. What is the ratio of the Rating (1=low 6=high) in Senegal in 2008 to that in 2010?
Your answer should be compact. 0.88. What is the ratio of the Rating (1=low 6=high) of Sub-Saharan Africa (developing only) in 2008 to that in 2011?
Provide a short and direct response. 1. What is the ratio of the Rating (1=low 6=high) of Nepal in 2008 to that in 2011?
Give a very brief answer. 1. What is the ratio of the Rating (1=low 6=high) in Senegal in 2008 to that in 2011?
Your answer should be compact. 0.88. What is the ratio of the Rating (1=low 6=high) in Sierra Leone in 2008 to that in 2011?
Offer a very short reply. 1. What is the ratio of the Rating (1=low 6=high) of Sub-Saharan Africa (developing only) in 2008 to that in 2012?
Your answer should be very brief. 1.02. What is the ratio of the Rating (1=low 6=high) of Nepal in 2008 to that in 2012?
Keep it short and to the point. 1.17. What is the ratio of the Rating (1=low 6=high) in Senegal in 2008 to that in 2012?
Keep it short and to the point. 0.88. What is the ratio of the Rating (1=low 6=high) in Sierra Leone in 2008 to that in 2012?
Keep it short and to the point. 1.17. What is the ratio of the Rating (1=low 6=high) in Sub-Saharan Africa (developing only) in 2008 to that in 2013?
Your answer should be very brief. 1.04. What is the ratio of the Rating (1=low 6=high) in Sub-Saharan Africa (developing only) in 2008 to that in 2014?
Keep it short and to the point. 1.07. What is the ratio of the Rating (1=low 6=high) in Senegal in 2008 to that in 2014?
Keep it short and to the point. 0.88. What is the ratio of the Rating (1=low 6=high) of Sierra Leone in 2008 to that in 2014?
Offer a terse response. 1.17. What is the ratio of the Rating (1=low 6=high) of Sub-Saharan Africa (developing only) in 2009 to that in 2010?
Offer a terse response. 1.02. What is the ratio of the Rating (1=low 6=high) of Nepal in 2009 to that in 2010?
Ensure brevity in your answer.  0.88. What is the ratio of the Rating (1=low 6=high) in Senegal in 2009 to that in 2010?
Offer a terse response. 1. What is the ratio of the Rating (1=low 6=high) of Sierra Leone in 2009 to that in 2010?
Give a very brief answer. 1. What is the ratio of the Rating (1=low 6=high) of Sub-Saharan Africa (developing only) in 2009 to that in 2011?
Offer a terse response. 1. What is the ratio of the Rating (1=low 6=high) in Senegal in 2009 to that in 2011?
Your answer should be very brief. 1. What is the ratio of the Rating (1=low 6=high) of Sub-Saharan Africa (developing only) in 2009 to that in 2012?
Your response must be concise. 1.02. What is the ratio of the Rating (1=low 6=high) of Nepal in 2009 to that in 2012?
Offer a terse response. 1.17. What is the ratio of the Rating (1=low 6=high) in Sierra Leone in 2009 to that in 2012?
Keep it short and to the point. 1.17. What is the ratio of the Rating (1=low 6=high) in Sub-Saharan Africa (developing only) in 2009 to that in 2013?
Keep it short and to the point. 1.04. What is the ratio of the Rating (1=low 6=high) in Nepal in 2009 to that in 2013?
Ensure brevity in your answer.  1.17. What is the ratio of the Rating (1=low 6=high) in Senegal in 2009 to that in 2013?
Provide a succinct answer. 1. What is the ratio of the Rating (1=low 6=high) of Sierra Leone in 2009 to that in 2013?
Give a very brief answer. 1.17. What is the ratio of the Rating (1=low 6=high) in Sub-Saharan Africa (developing only) in 2009 to that in 2014?
Make the answer very short. 1.07. What is the ratio of the Rating (1=low 6=high) in Nepal in 2009 to that in 2014?
Provide a succinct answer. 1.17. What is the ratio of the Rating (1=low 6=high) of Sierra Leone in 2009 to that in 2014?
Your response must be concise. 1.17. What is the ratio of the Rating (1=low 6=high) of Sub-Saharan Africa (developing only) in 2010 to that in 2011?
Your response must be concise. 0.99. What is the ratio of the Rating (1=low 6=high) in Sub-Saharan Africa (developing only) in 2010 to that in 2012?
Your answer should be compact. 1.01. What is the ratio of the Rating (1=low 6=high) in Nepal in 2010 to that in 2012?
Offer a terse response. 1.33. What is the ratio of the Rating (1=low 6=high) of Sierra Leone in 2010 to that in 2012?
Offer a very short reply. 1.17. What is the ratio of the Rating (1=low 6=high) of Sub-Saharan Africa (developing only) in 2010 to that in 2013?
Provide a short and direct response. 1.03. What is the ratio of the Rating (1=low 6=high) of Nepal in 2010 to that in 2013?
Your response must be concise. 1.33. What is the ratio of the Rating (1=low 6=high) in Senegal in 2010 to that in 2013?
Ensure brevity in your answer.  1. What is the ratio of the Rating (1=low 6=high) of Sierra Leone in 2010 to that in 2013?
Your response must be concise. 1.17. What is the ratio of the Rating (1=low 6=high) of Sub-Saharan Africa (developing only) in 2010 to that in 2014?
Your response must be concise. 1.06. What is the ratio of the Rating (1=low 6=high) in Nepal in 2010 to that in 2014?
Your response must be concise. 1.33. What is the ratio of the Rating (1=low 6=high) of Sierra Leone in 2010 to that in 2014?
Offer a very short reply. 1.17. What is the ratio of the Rating (1=low 6=high) of Sub-Saharan Africa (developing only) in 2011 to that in 2012?
Keep it short and to the point. 1.02. What is the ratio of the Rating (1=low 6=high) of Nepal in 2011 to that in 2012?
Provide a short and direct response. 1.17. What is the ratio of the Rating (1=low 6=high) of Sub-Saharan Africa (developing only) in 2011 to that in 2013?
Offer a terse response. 1.04. What is the ratio of the Rating (1=low 6=high) in Senegal in 2011 to that in 2013?
Your answer should be very brief. 1. What is the ratio of the Rating (1=low 6=high) in Sierra Leone in 2011 to that in 2013?
Offer a terse response. 1.17. What is the ratio of the Rating (1=low 6=high) of Sub-Saharan Africa (developing only) in 2011 to that in 2014?
Ensure brevity in your answer.  1.07. What is the ratio of the Rating (1=low 6=high) of Sub-Saharan Africa (developing only) in 2012 to that in 2013?
Offer a terse response. 1.02. What is the ratio of the Rating (1=low 6=high) in Sub-Saharan Africa (developing only) in 2012 to that in 2014?
Provide a succinct answer. 1.05. What is the ratio of the Rating (1=low 6=high) in Nepal in 2012 to that in 2014?
Give a very brief answer. 1. What is the ratio of the Rating (1=low 6=high) in Sub-Saharan Africa (developing only) in 2013 to that in 2014?
Give a very brief answer. 1.03. What is the ratio of the Rating (1=low 6=high) of Nepal in 2013 to that in 2014?
Ensure brevity in your answer.  1. What is the ratio of the Rating (1=low 6=high) in Sierra Leone in 2013 to that in 2014?
Offer a very short reply. 1. What is the difference between the highest and the second highest Rating (1=low 6=high) in Sub-Saharan Africa (developing only)?
Provide a short and direct response. 0. What is the difference between the highest and the second highest Rating (1=low 6=high) of Nepal?
Make the answer very short. 0.5. What is the difference between the highest and the lowest Rating (1=low 6=high) of Sub-Saharan Africa (developing only)?
Your answer should be compact. 0.24. What is the difference between the highest and the lowest Rating (1=low 6=high) in Nepal?
Provide a succinct answer. 1. What is the difference between the highest and the lowest Rating (1=low 6=high) of Sierra Leone?
Provide a succinct answer. 0.5. 